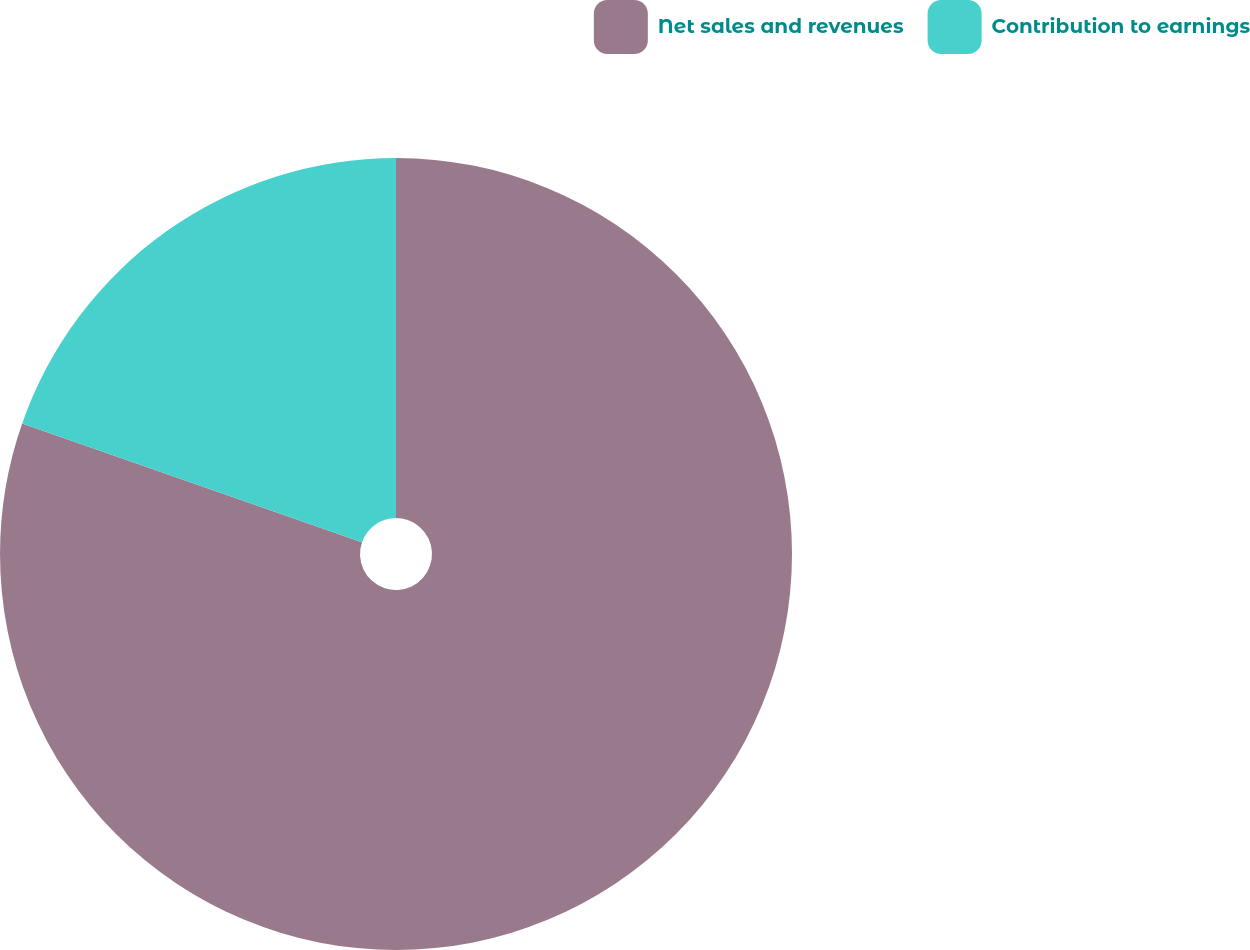Convert chart to OTSL. <chart><loc_0><loc_0><loc_500><loc_500><pie_chart><fcel>Net sales and revenues<fcel>Contribution to earnings<nl><fcel>80.35%<fcel>19.65%<nl></chart> 